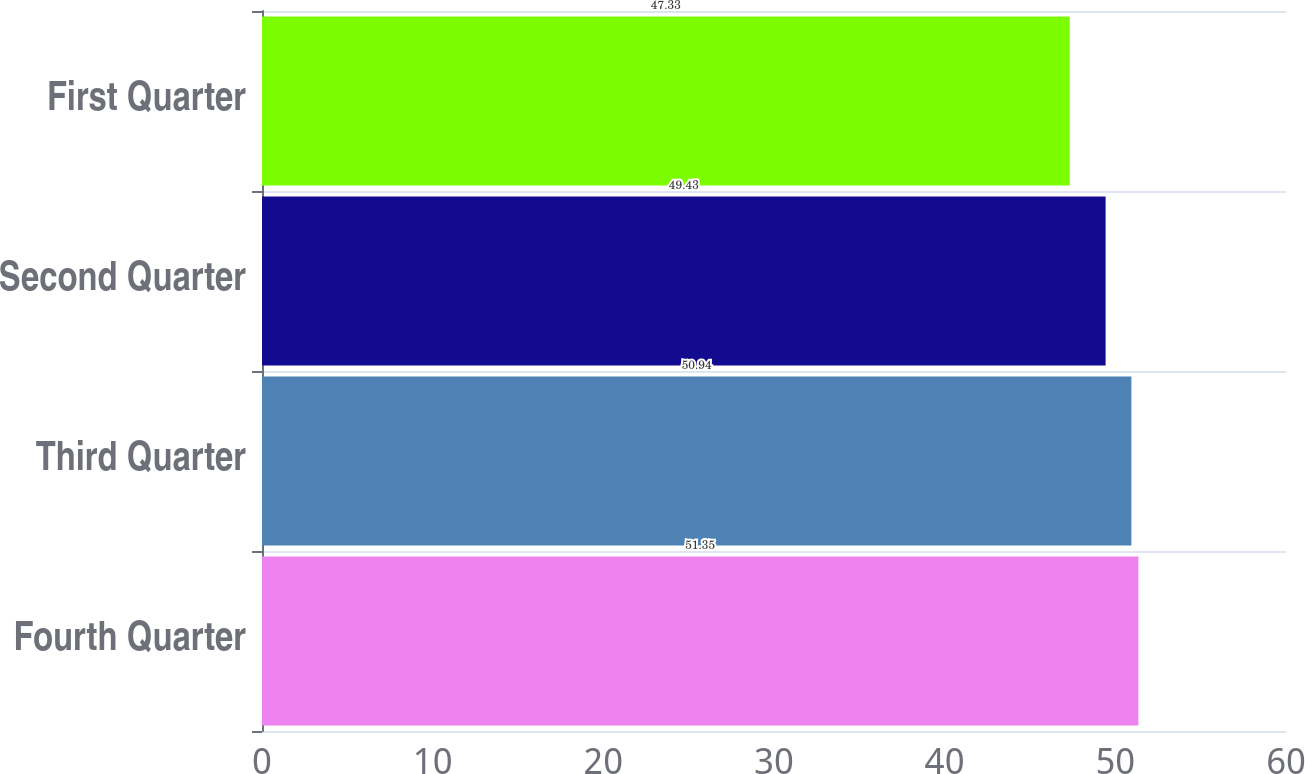Convert chart. <chart><loc_0><loc_0><loc_500><loc_500><bar_chart><fcel>Fourth Quarter<fcel>Third Quarter<fcel>Second Quarter<fcel>First Quarter<nl><fcel>51.35<fcel>50.94<fcel>49.43<fcel>47.33<nl></chart> 